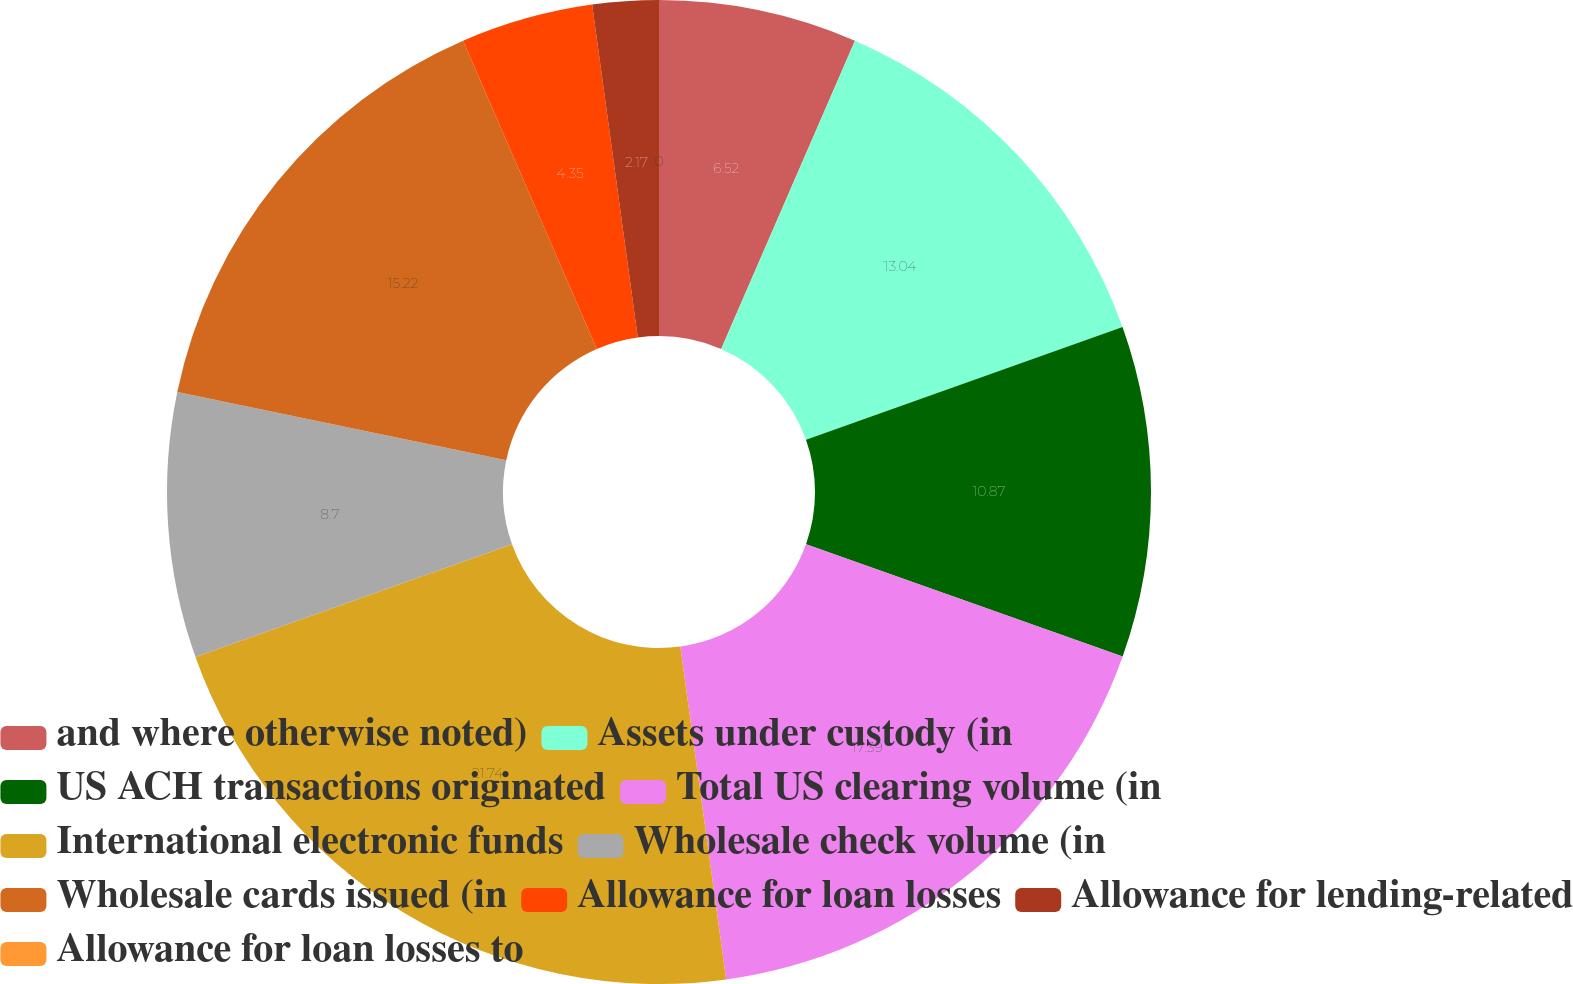Convert chart. <chart><loc_0><loc_0><loc_500><loc_500><pie_chart><fcel>and where otherwise noted)<fcel>Assets under custody (in<fcel>US ACH transactions originated<fcel>Total US clearing volume (in<fcel>International electronic funds<fcel>Wholesale check volume (in<fcel>Wholesale cards issued (in<fcel>Allowance for loan losses<fcel>Allowance for lending-related<fcel>Allowance for loan losses to<nl><fcel>6.52%<fcel>13.04%<fcel>10.87%<fcel>17.39%<fcel>21.74%<fcel>8.7%<fcel>15.22%<fcel>4.35%<fcel>2.17%<fcel>0.0%<nl></chart> 